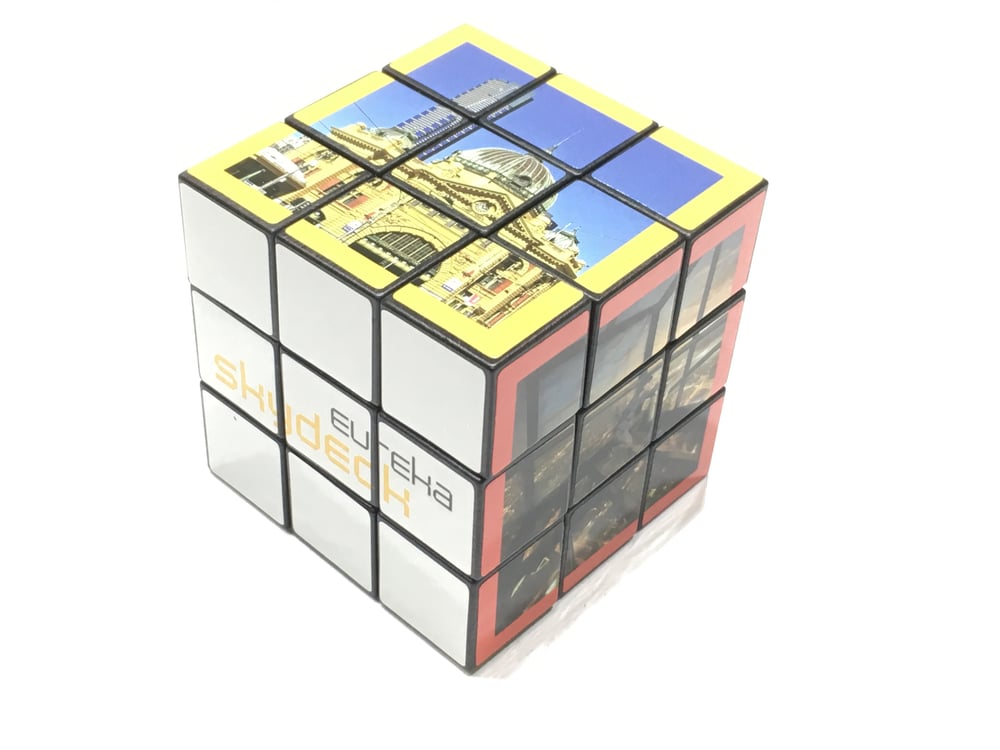Considering the partial images visible on the cube, which famous landmark might the complete picture represent when the cube is solved, and what clues lead to this deduction? The complete picture on the cube might represent a famous historic building known for its architectural significance. The visible segments show elements such as a dome, classical arches, and intricate decorative details, suggesting a grand and important structure. The word 'SHINDECH' could be part of the name or a related term associated with the landmark. The architectural style, particularly the dome and windows, is reminiscent of iconic buildings like the United States Capitol, St. Paul's Cathedral, or other renowned institutions. While it's challenging to identify the exact landmark without more context, these clues point towards significant and visually grand architecture. 